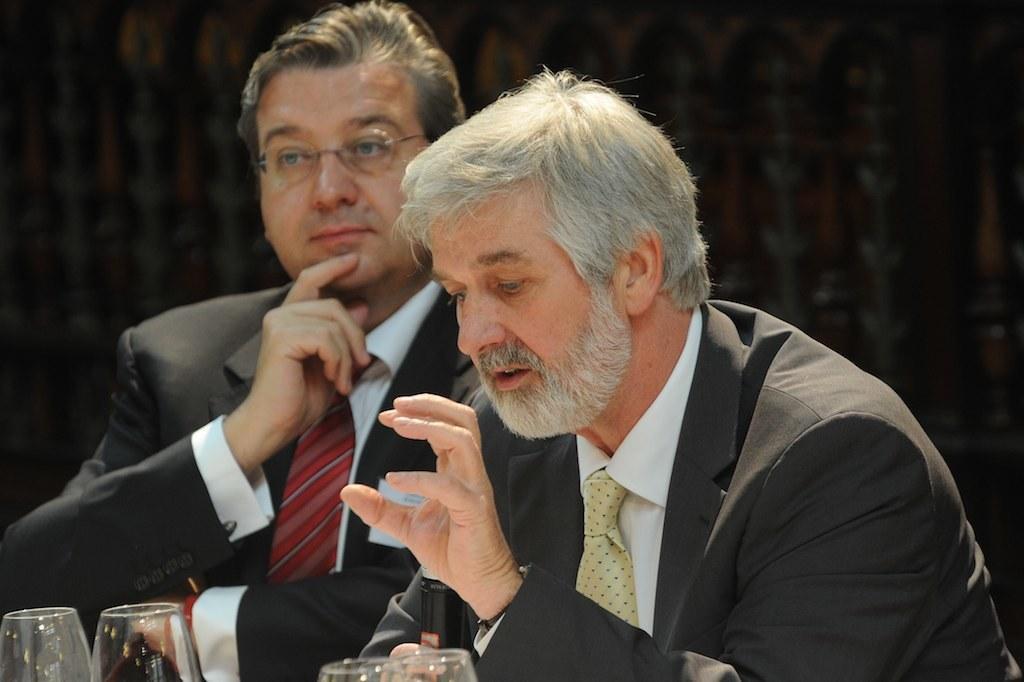Describe this image in one or two sentences. This is the picture of two people wearing suit and sitting in front of some glasses. 